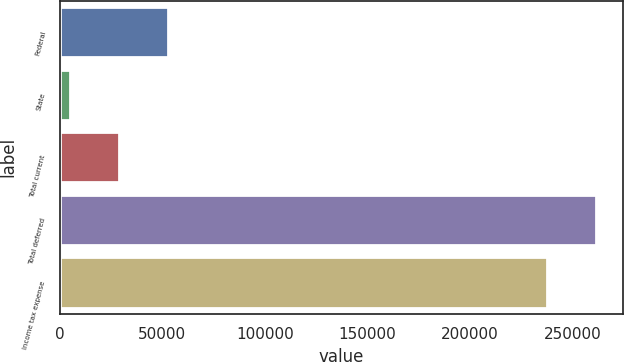Convert chart. <chart><loc_0><loc_0><loc_500><loc_500><bar_chart><fcel>Federal<fcel>State<fcel>Total current<fcel>Total deferred<fcel>Income tax expense<nl><fcel>52868.8<fcel>4763<fcel>28815.9<fcel>261773<fcel>237720<nl></chart> 